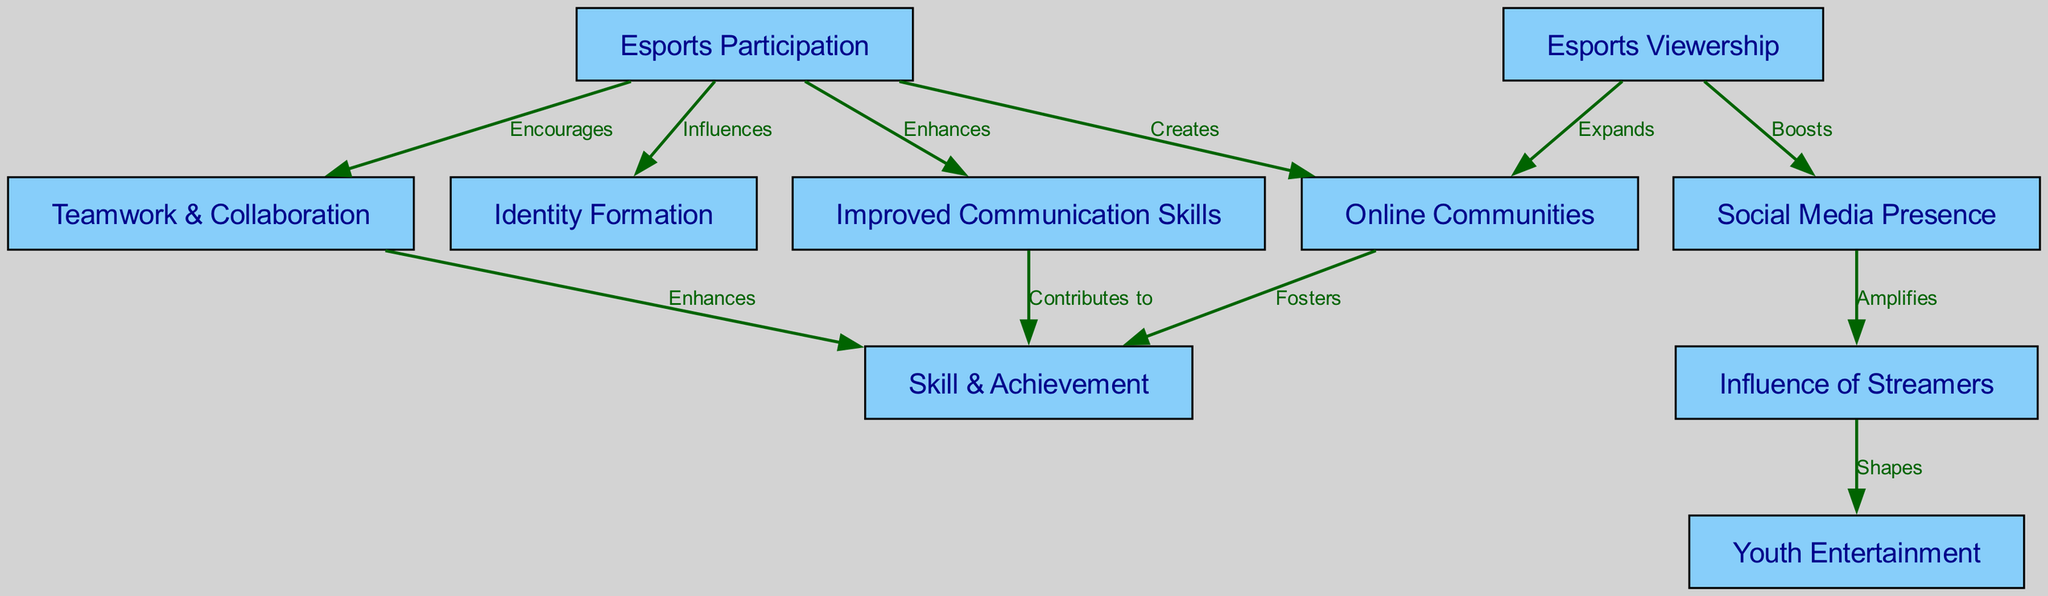What are the main outcomes of esports participation? The diagram suggests that esports participation results in improved communication skills, teamwork and collaboration, influences identity formation, and creates online communities.
Answer: Improved communication skills, teamwork & collaboration, identity formation, online communities How many nodes are in the diagram? By counting all the unique nodes listed in the diagram, we can see there are 10 nodes in total.
Answer: 10 Which node contributes to skill achievement through improved communication skills? The edge labeled "Contributes to" connects improved communication skills and skill achievement, indicating that improved communication skills help or influence skill achievement.
Answer: Skill achievement What relationship is shown between viewership and online communities? The diagram depicts a connection from viewership to online communities labeled "Expands," meaning that the presence of viewers leads to an increase in online communities.
Answer: Expands What does social media presence amplify? According to the diagram, social media presence amplifies the influence of streamers, which indicates a direct relationship between these two nodes.
Answer: Influence of streamers Which node is influenced by esports participation? The diagram illustrates that esports participation influences identity formation, showing that participation has a direct impact on how youth form their identities.
Answer: Identity formation How does teamwork and collaboration relate to skill achievement? The diagram shows a direct edge labeled "Enhances" connecting teamwork & collaboration and skill achievement, indicating that teamwork contributes to enhancing skills.
Answer: Enhances What main influence do streamers have on youth? The diagram indicates that streamers shape youth entertainment, suggesting their content and influence play a significant role in how youth engage with entertainment.
Answer: Shapes What role do online communities play in skill achievement? The diagram highlights a relationship labeled "Fosters" between online communities and skill achievement, indicating that being part of online communities supports or nurtures skill achievement.
Answer: Fosters 